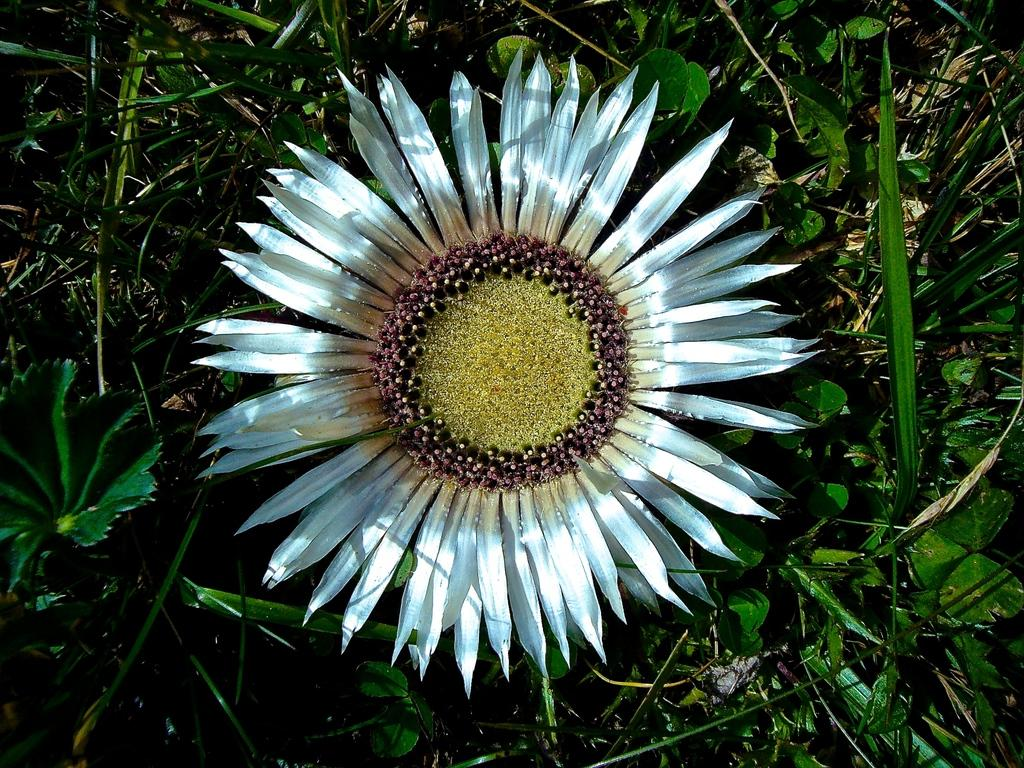What is the main subject of the image? There is a flower in the center of the image. What else can be seen around the flower? There are plants surrounding the flower, and dry grass is present around the flower. What example of death can be seen in the image? There is no example of death present in the image; it features a flower surrounded by plants and dry grass. 